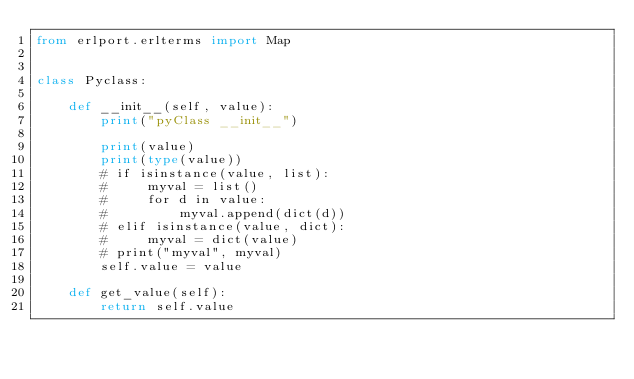<code> <loc_0><loc_0><loc_500><loc_500><_Python_>from erlport.erlterms import Map


class Pyclass:

    def __init__(self, value):
        print("pyClass __init__")

        print(value)
        print(type(value))
        # if isinstance(value, list):
        #     myval = list()
        #     for d in value:
        #         myval.append(dict(d))
        # elif isinstance(value, dict):
        #     myval = dict(value)
        # print("myval", myval)
        self.value = value

    def get_value(self):
        return self.value
</code> 